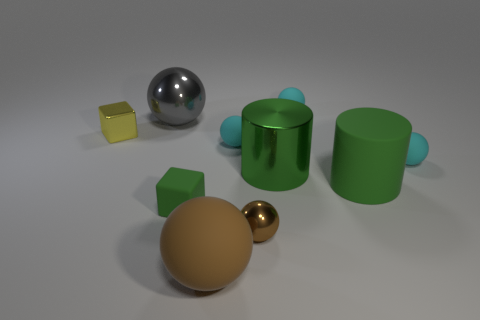There is another object that is the same shape as the yellow object; what is its color?
Give a very brief answer. Green. Are there any other things that have the same color as the big shiny ball?
Offer a very short reply. No. Do the green object that is on the left side of the large brown matte object and the matte thing that is behind the big metallic sphere have the same size?
Your answer should be compact. Yes. Is the number of green cylinders that are behind the large gray thing the same as the number of small cyan rubber balls that are left of the tiny yellow block?
Your answer should be compact. Yes. There is a green cube; is its size the same as the brown sphere that is right of the brown matte ball?
Your answer should be compact. Yes. There is a green shiny thing to the right of the big gray sphere; is there a tiny brown object to the left of it?
Your response must be concise. Yes. Are there any brown metallic objects of the same shape as the small green thing?
Your answer should be compact. No. What number of yellow metallic cubes are to the left of the small cyan ball on the right side of the cyan object that is behind the tiny yellow metallic block?
Make the answer very short. 1. There is a metallic cube; is its color the same as the rubber sphere that is behind the tiny yellow block?
Your response must be concise. No. How many things are tiny cyan things to the left of the brown shiny ball or balls that are behind the big rubber sphere?
Your answer should be compact. 5. 